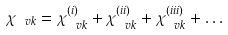Convert formula to latex. <formula><loc_0><loc_0><loc_500><loc_500>\chi _ { \ v k } = \chi ^ { ( i ) } _ { \ v k } + \chi ^ { ( i i ) } _ { \ v k } + \chi ^ { ( i i i ) } _ { \ v k } + \dots</formula> 